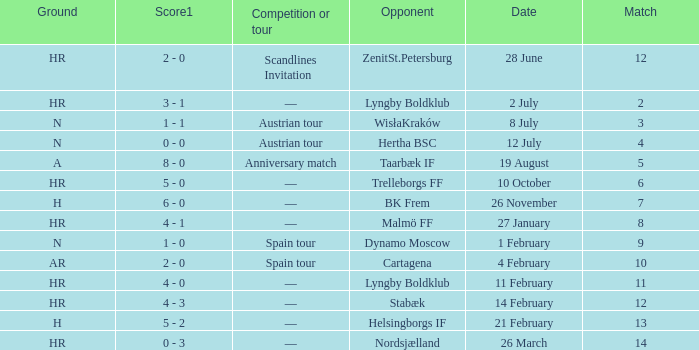In which competition or tour was nordsjælland the opponent with a hr Ground? —. 